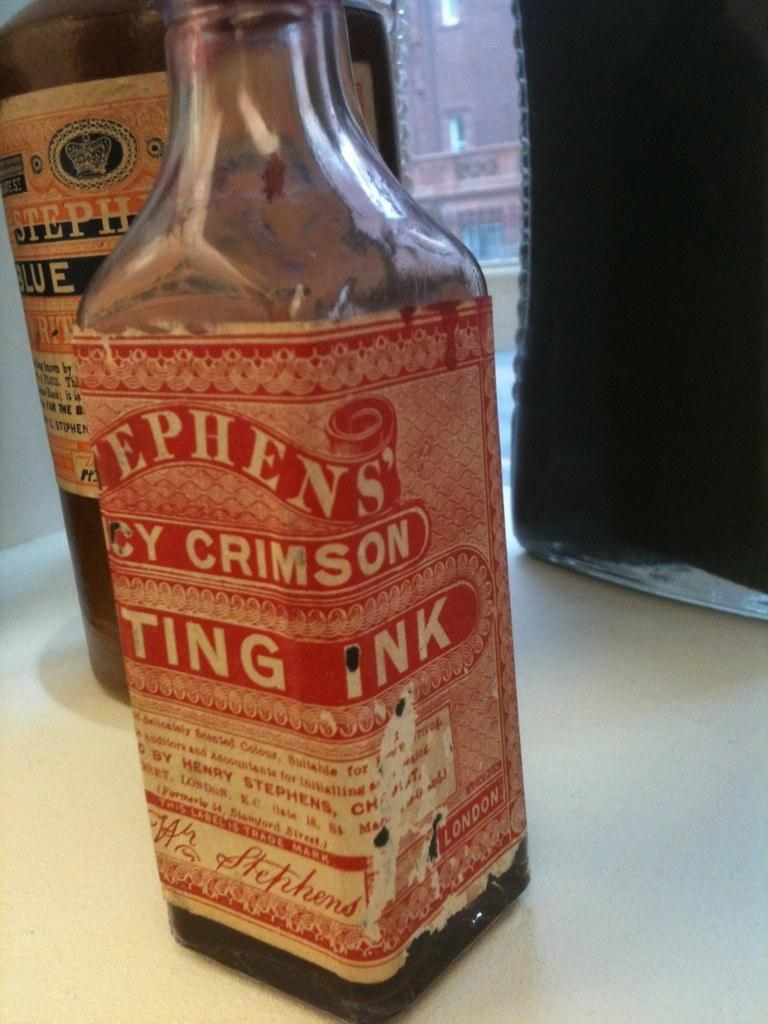<image>
Write a terse but informative summary of the picture. An ink bottle with the brand name of Stephen's 